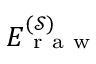Convert formula to latex. <formula><loc_0><loc_0><loc_500><loc_500>E _ { r a w } ^ { ( \mathcal { S } ) }</formula> 